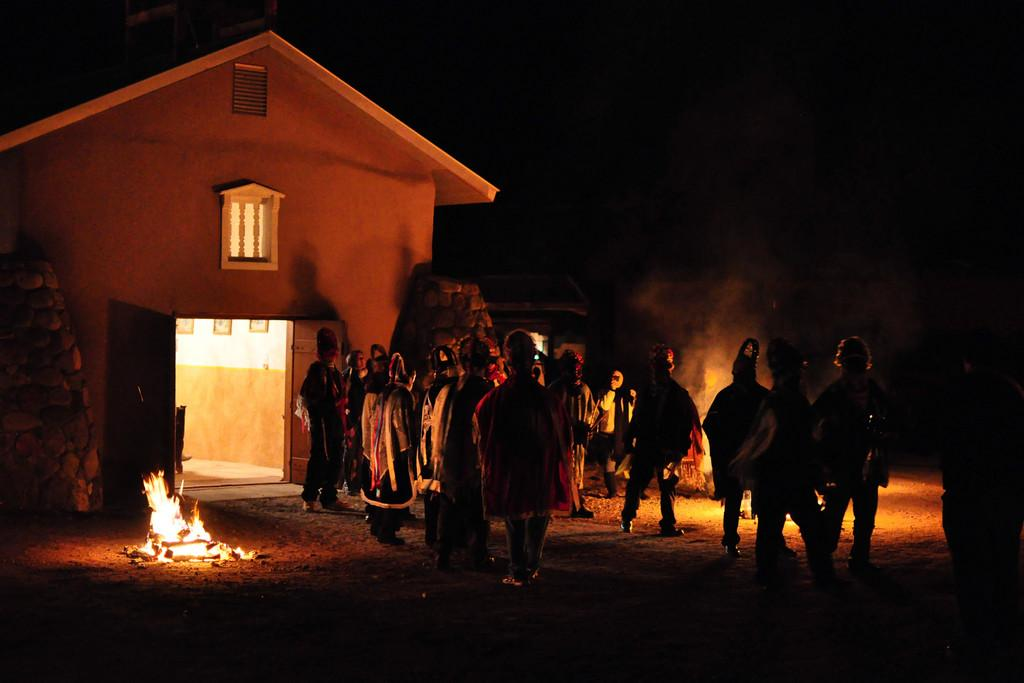What time of day was the image taken? The image was taken during night. What structure is visible in the image? There is a house in the image. Are there any people present in the image? Yes, there are people in front of the house. What is happening on the floor in the middle of the image? There is a fire on the floor in the middle of the image. What type of leaf is being used as a pig's bed in the image? There is no leaf or pig present in the image. How many bricks are visible in the image? There is no mention of bricks in the image, so it is not possible to determine their number. 